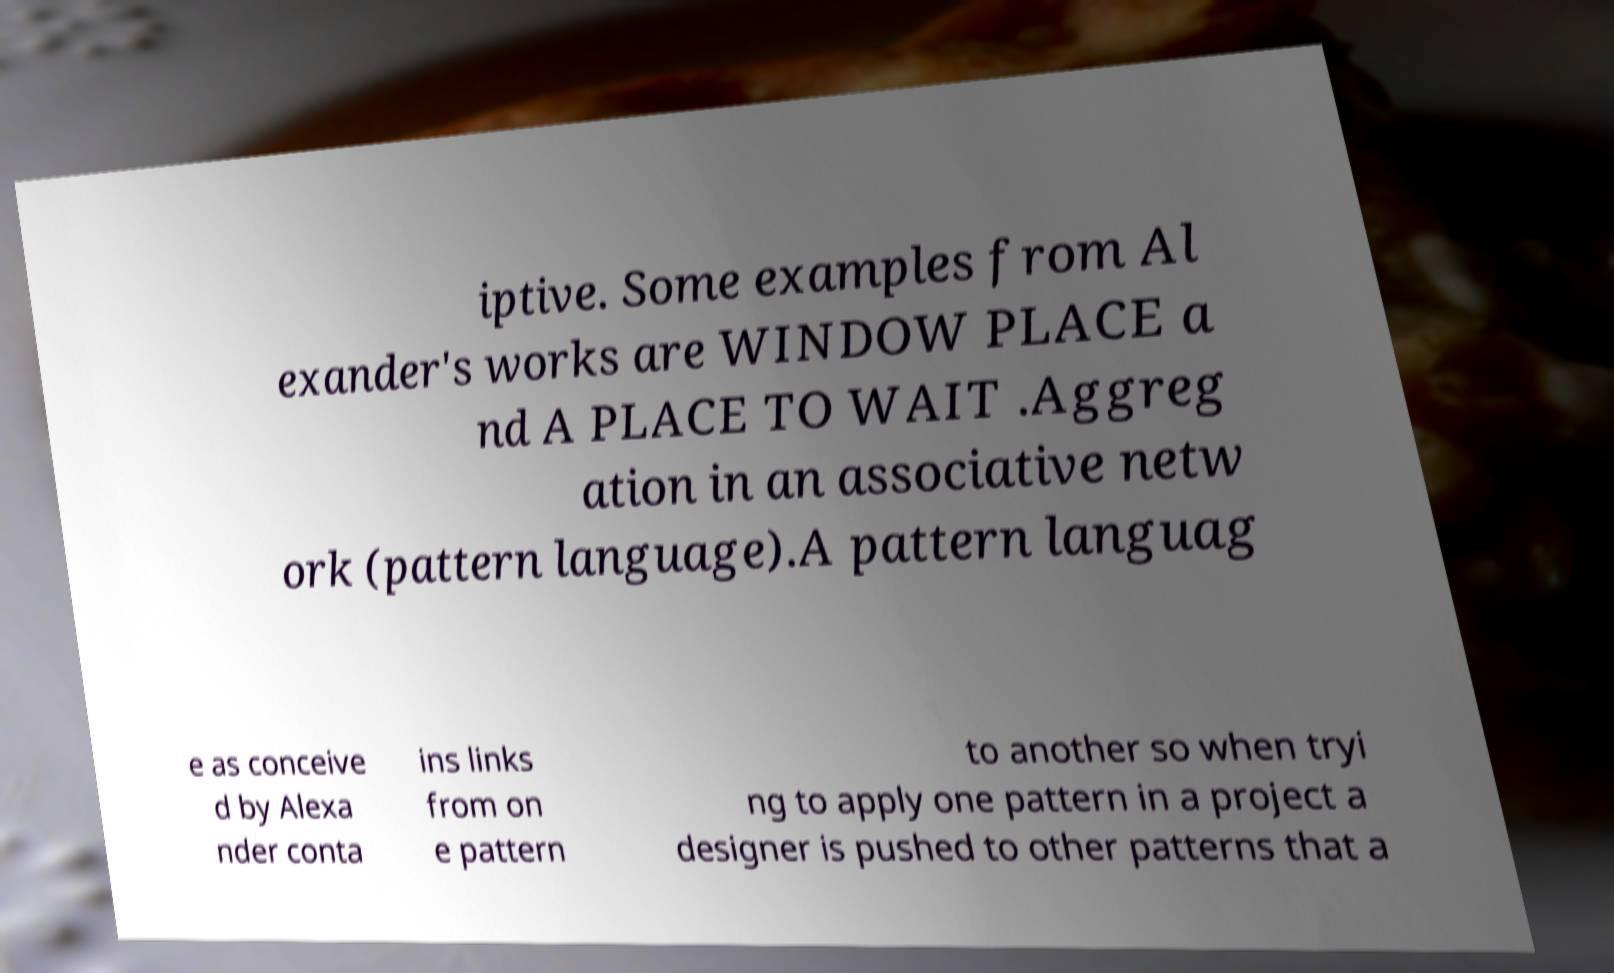I need the written content from this picture converted into text. Can you do that? iptive. Some examples from Al exander's works are WINDOW PLACE a nd A PLACE TO WAIT .Aggreg ation in an associative netw ork (pattern language).A pattern languag e as conceive d by Alexa nder conta ins links from on e pattern to another so when tryi ng to apply one pattern in a project a designer is pushed to other patterns that a 